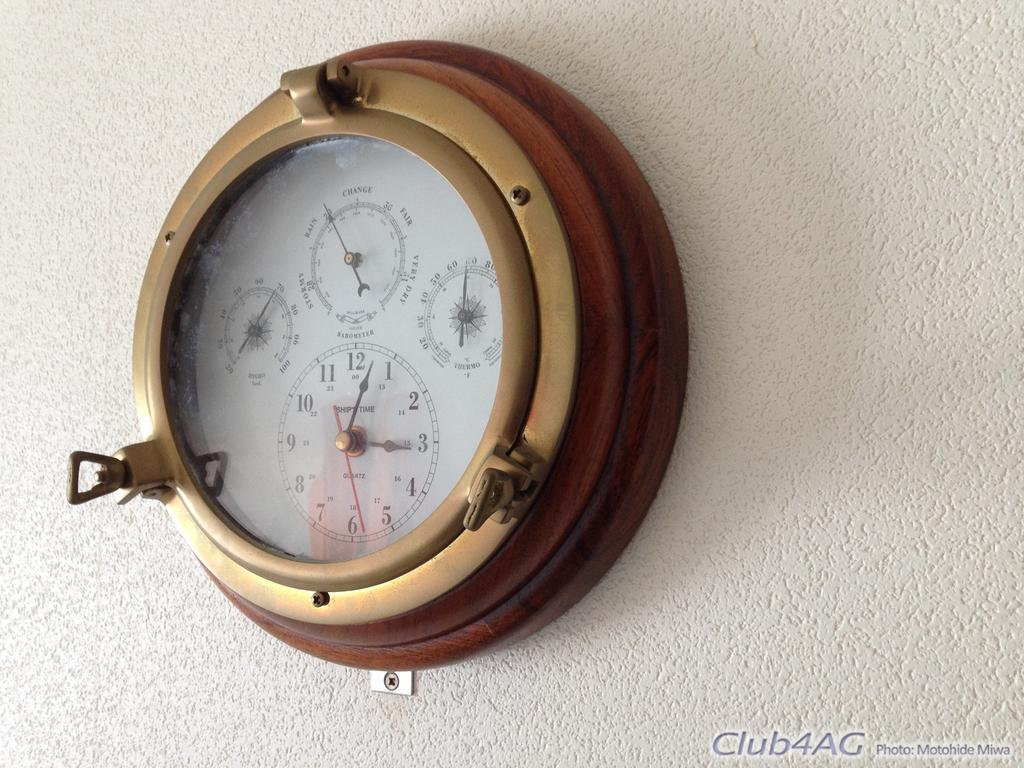<image>
Create a compact narrative representing the image presented. A clock with four faces points toward 3:03. 